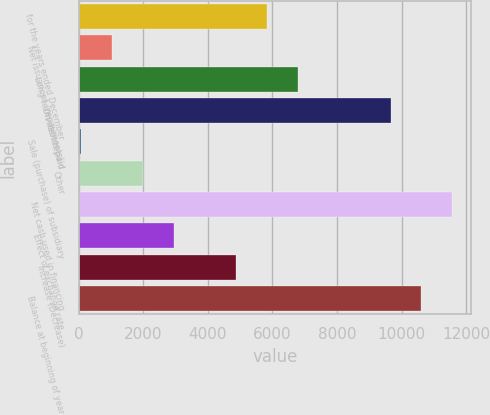Convert chart to OTSL. <chart><loc_0><loc_0><loc_500><loc_500><bar_chart><fcel>for the years ended December<fcel>Net issuances (repayments) -<fcel>Long-term debt repaid<fcel>Dividends paid<fcel>Sale (purchase) of subsidiary<fcel>Other<fcel>Net cash used in financing<fcel>Effect of exchange rate<fcel>Increase (Decrease)<fcel>Balance at beginning of year<nl><fcel>5823<fcel>1038<fcel>6780<fcel>9651<fcel>81<fcel>1995<fcel>11565<fcel>2952<fcel>4866<fcel>10608<nl></chart> 